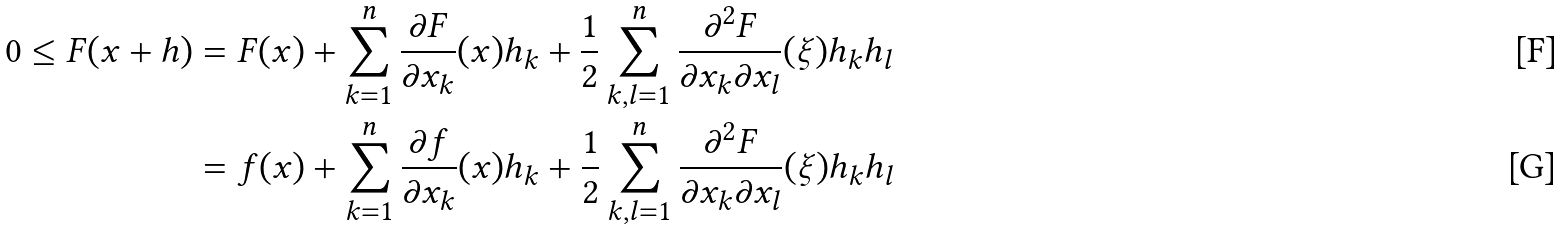<formula> <loc_0><loc_0><loc_500><loc_500>0 \leq F ( x + h ) & = F ( x ) + \sum _ { k = 1 } ^ { n } \frac { \partial F } { \partial x _ { k } } ( x ) h _ { k } + \frac { 1 } { 2 } \sum _ { k , l = 1 } ^ { n } \frac { \partial ^ { 2 } F } { \partial x _ { k } \partial x _ { l } } ( \xi ) h _ { k } h _ { l } \\ & = f ( x ) + \sum _ { k = 1 } ^ { n } \frac { \partial f } { \partial x _ { k } } ( x ) h _ { k } + \frac { 1 } { 2 } \sum _ { k , l = 1 } ^ { n } \frac { \partial ^ { 2 } F } { \partial x _ { k } \partial x _ { l } } ( \xi ) h _ { k } h _ { l }</formula> 